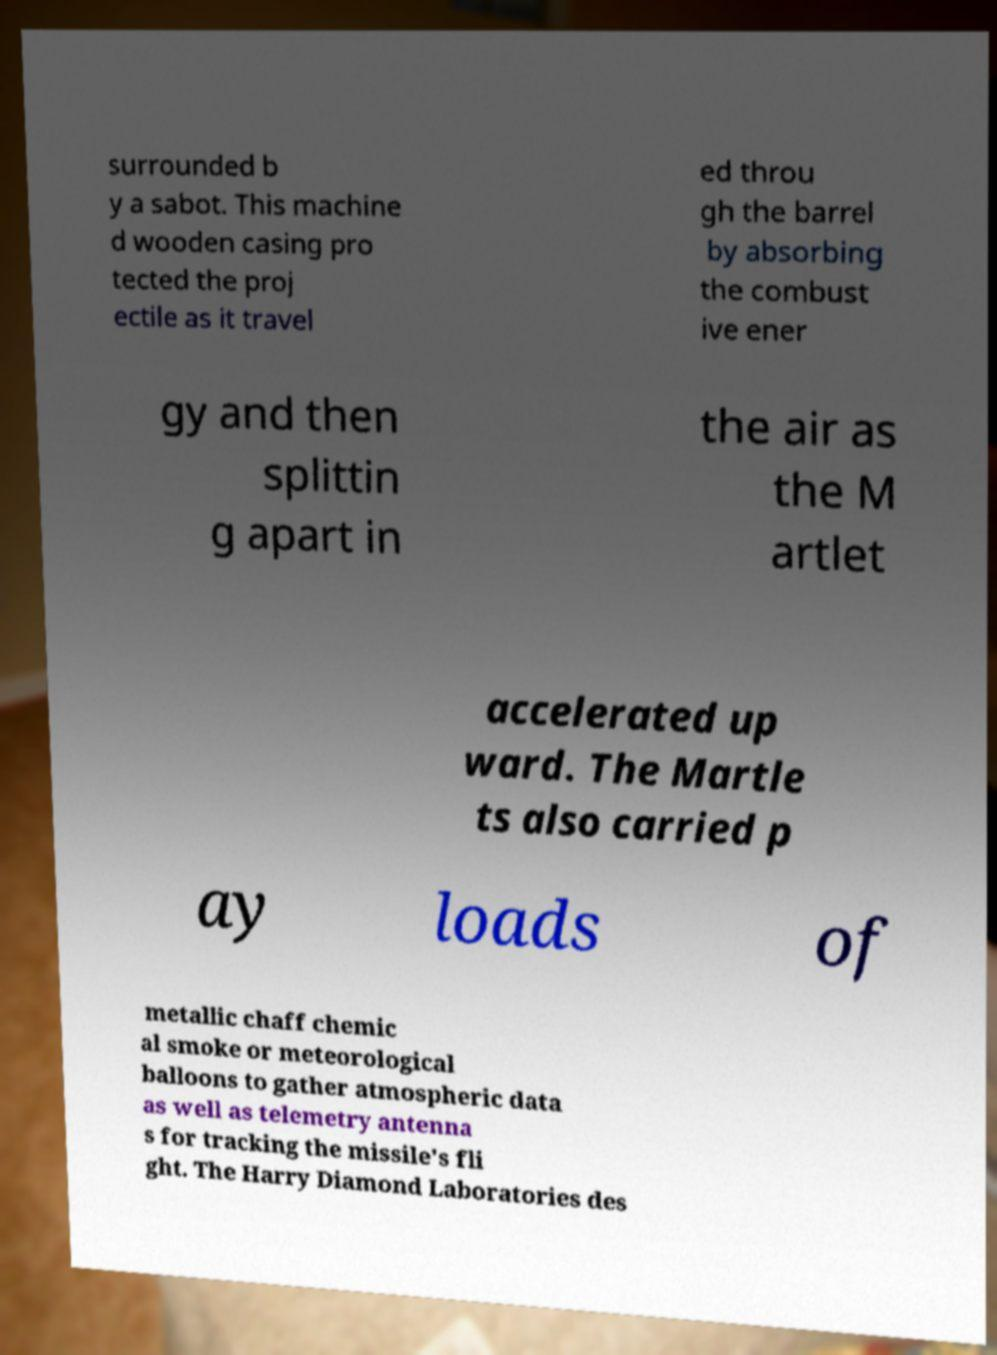Could you extract and type out the text from this image? surrounded b y a sabot. This machine d wooden casing pro tected the proj ectile as it travel ed throu gh the barrel by absorbing the combust ive ener gy and then splittin g apart in the air as the M artlet accelerated up ward. The Martle ts also carried p ay loads of metallic chaff chemic al smoke or meteorological balloons to gather atmospheric data as well as telemetry antenna s for tracking the missile's fli ght. The Harry Diamond Laboratories des 